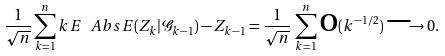<formula> <loc_0><loc_0><loc_500><loc_500>\frac { 1 } { \sqrt { n } } \sum _ { k = 1 } ^ { n } k \, E \ A b s { E ( Z _ { k } | \mathcal { G } _ { k - 1 } ) - Z _ { k - 1 } } = \frac { 1 } { \sqrt { n } } \, \sum _ { k = 1 } ^ { n } \text {o} ( k ^ { - 1 / 2 } ) \longrightarrow 0 .</formula> 